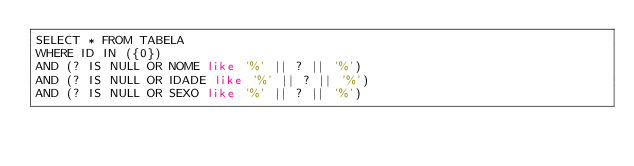Convert code to text. <code><loc_0><loc_0><loc_500><loc_500><_SQL_>SELECT * FROM TABELA
WHERE ID IN ({0})
AND (? IS NULL OR NOME like '%' || ? || '%')
AND (? IS NULL OR IDADE like '%' || ? || '%')
AND (? IS NULL OR SEXO like '%' || ? || '%')
</code> 